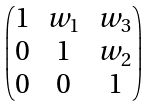<formula> <loc_0><loc_0><loc_500><loc_500>\begin{pmatrix} 1 & w _ { 1 } & w _ { 3 } \\ 0 & 1 & w _ { 2 } \\ 0 & 0 & 1 \end{pmatrix}</formula> 